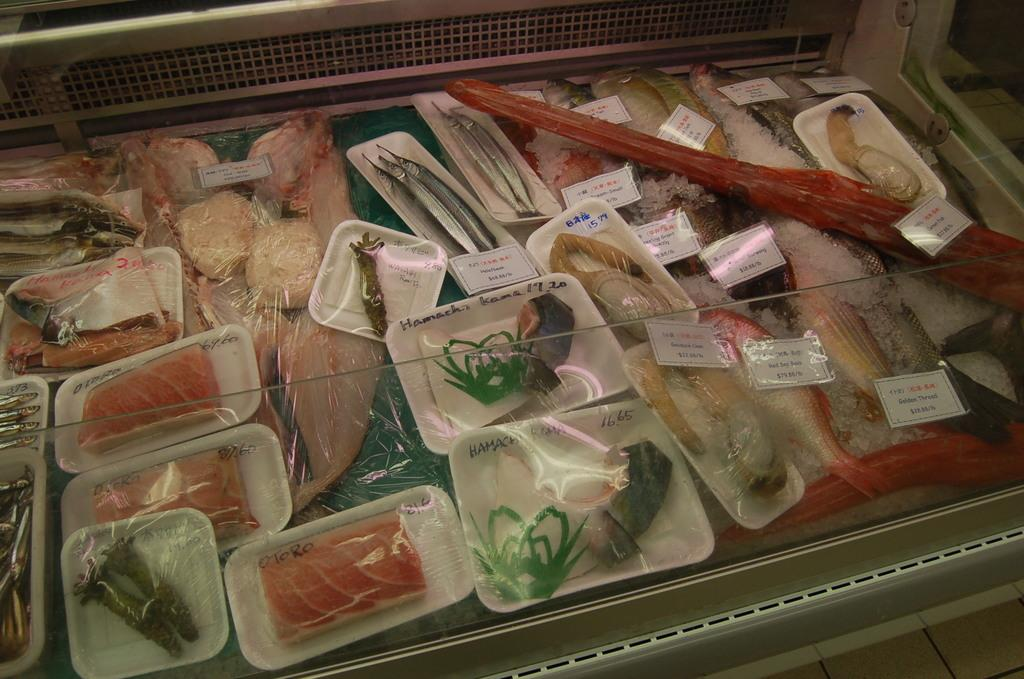What type of food is packed in the image? There is seafood packed in the image. How are the seafood items identified or labeled? Stickers are attached to the seafood. Where are the seafood and stickers located? They are in a tray. What can be said about the appearance of the seafood and stickers? The seafood and stickers are colorful. How many girls are holding a fan in the image? There are no girls or fans present in the image; it features seafood packed in a tray with colorful stickers. 